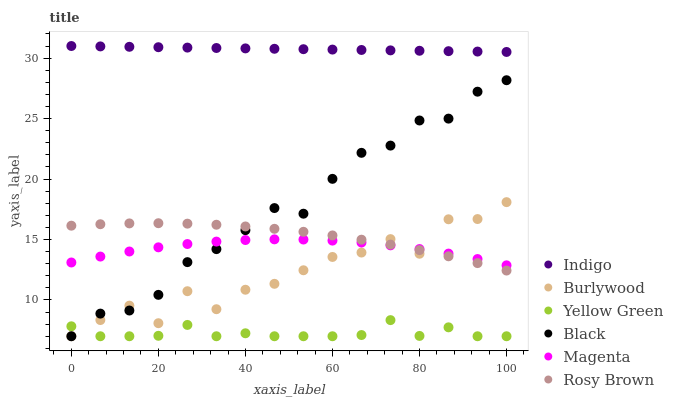Does Yellow Green have the minimum area under the curve?
Answer yes or no. Yes. Does Indigo have the maximum area under the curve?
Answer yes or no. Yes. Does Burlywood have the minimum area under the curve?
Answer yes or no. No. Does Burlywood have the maximum area under the curve?
Answer yes or no. No. Is Indigo the smoothest?
Answer yes or no. Yes. Is Burlywood the roughest?
Answer yes or no. Yes. Is Yellow Green the smoothest?
Answer yes or no. No. Is Yellow Green the roughest?
Answer yes or no. No. Does Yellow Green have the lowest value?
Answer yes or no. Yes. Does Rosy Brown have the lowest value?
Answer yes or no. No. Does Indigo have the highest value?
Answer yes or no. Yes. Does Burlywood have the highest value?
Answer yes or no. No. Is Burlywood less than Indigo?
Answer yes or no. Yes. Is Indigo greater than Yellow Green?
Answer yes or no. Yes. Does Rosy Brown intersect Burlywood?
Answer yes or no. Yes. Is Rosy Brown less than Burlywood?
Answer yes or no. No. Is Rosy Brown greater than Burlywood?
Answer yes or no. No. Does Burlywood intersect Indigo?
Answer yes or no. No. 